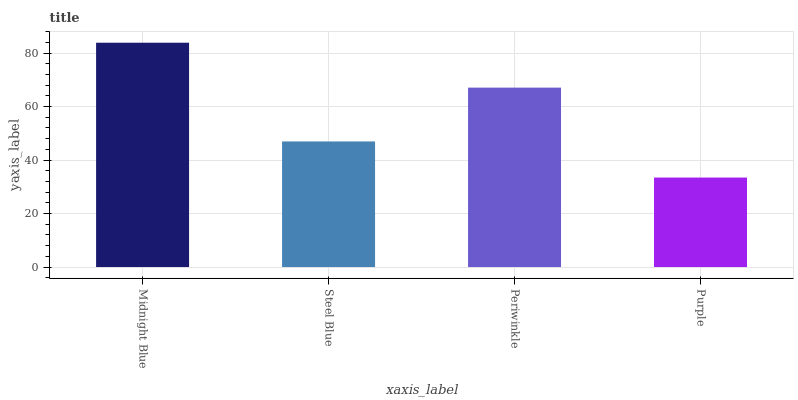Is Purple the minimum?
Answer yes or no. Yes. Is Midnight Blue the maximum?
Answer yes or no. Yes. Is Steel Blue the minimum?
Answer yes or no. No. Is Steel Blue the maximum?
Answer yes or no. No. Is Midnight Blue greater than Steel Blue?
Answer yes or no. Yes. Is Steel Blue less than Midnight Blue?
Answer yes or no. Yes. Is Steel Blue greater than Midnight Blue?
Answer yes or no. No. Is Midnight Blue less than Steel Blue?
Answer yes or no. No. Is Periwinkle the high median?
Answer yes or no. Yes. Is Steel Blue the low median?
Answer yes or no. Yes. Is Purple the high median?
Answer yes or no. No. Is Midnight Blue the low median?
Answer yes or no. No. 